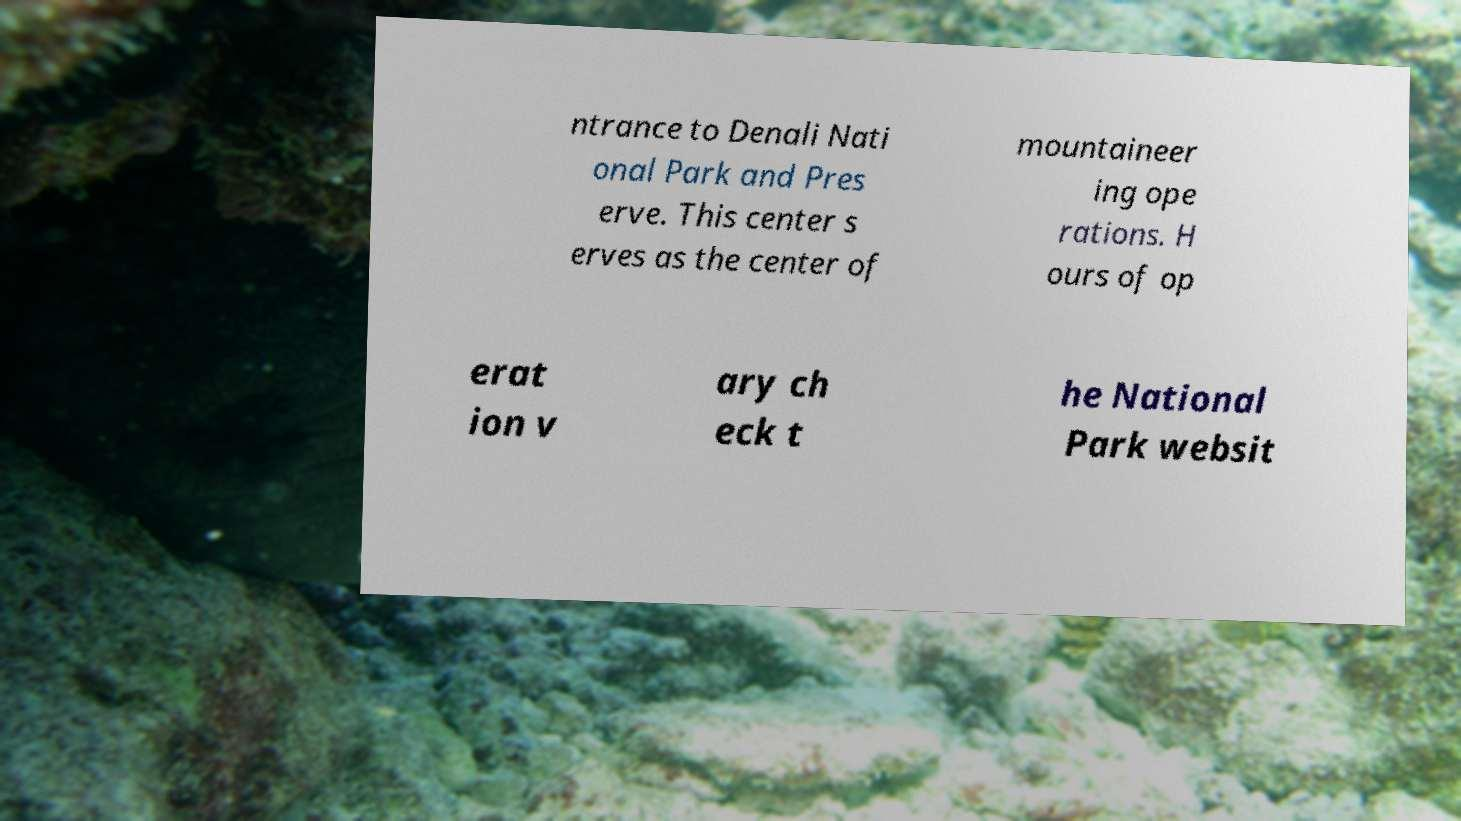I need the written content from this picture converted into text. Can you do that? ntrance to Denali Nati onal Park and Pres erve. This center s erves as the center of mountaineer ing ope rations. H ours of op erat ion v ary ch eck t he National Park websit 